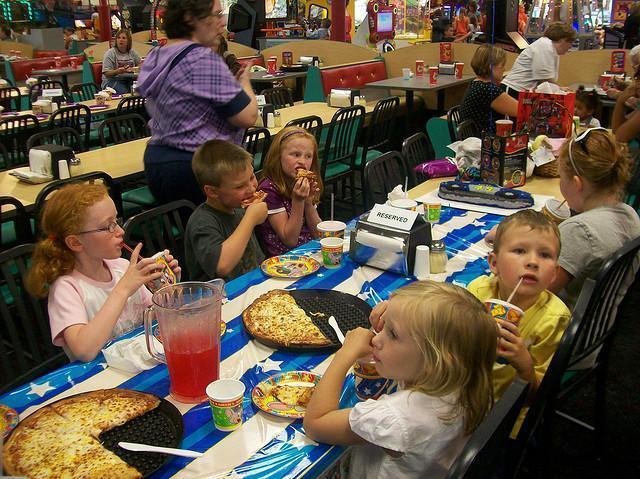What is a likely occasion for all the kids getting together?
Make your selection from the four choices given to correctly answer the question.
Options: Funeral, school, church, birthday party. Birthday party. 